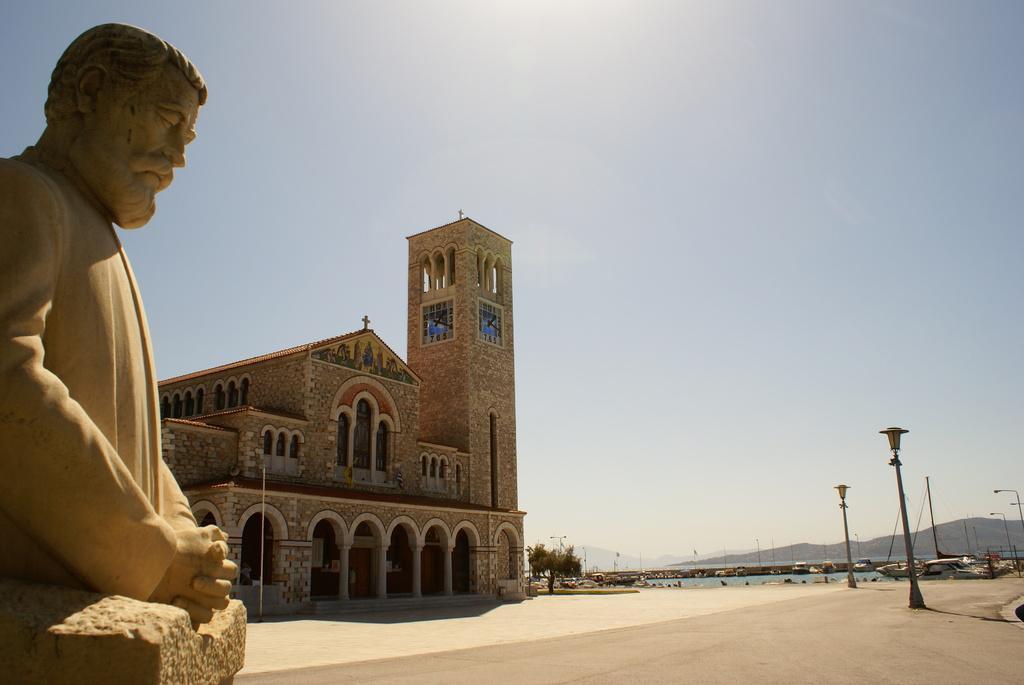In one or two sentences, can you explain what this image depicts? In this image I can see the statue of the person. In the background I can see the building, many poles and the tree. I can also see the water, mountains and the sky. 